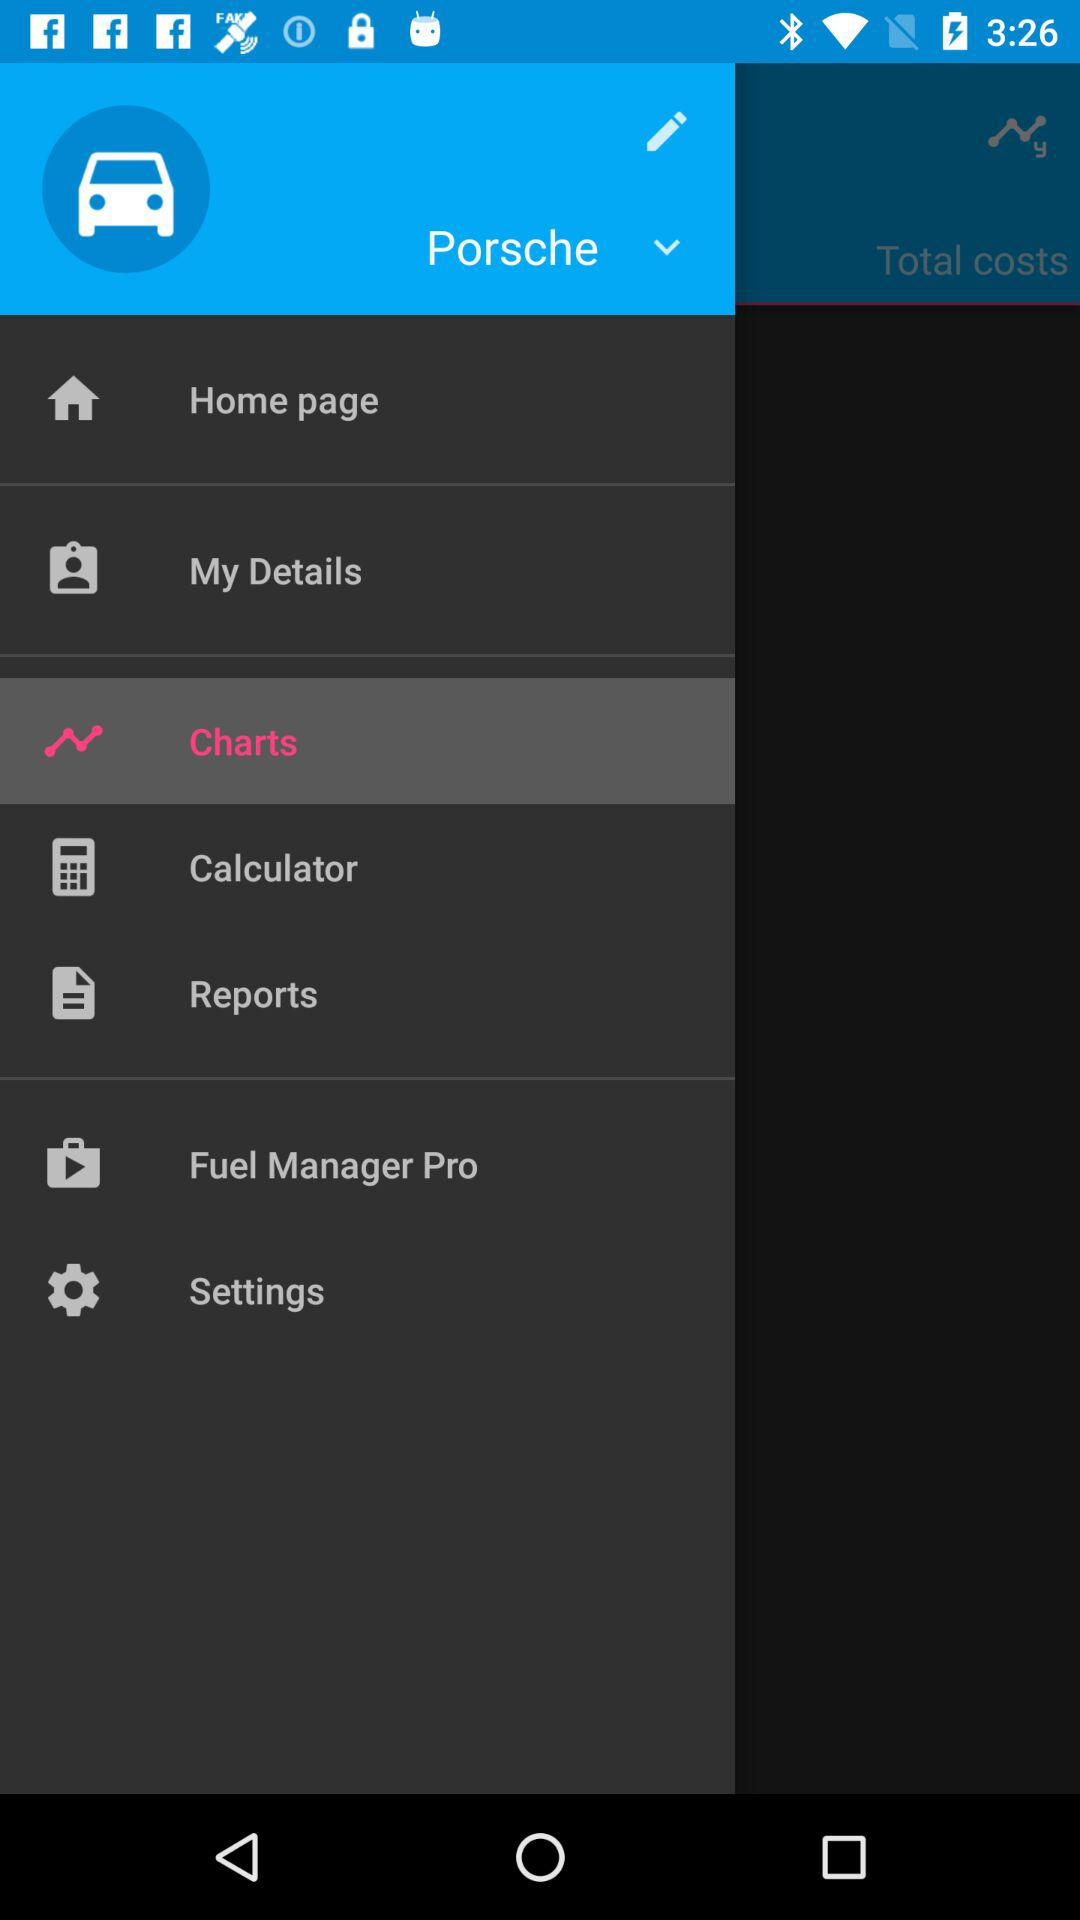What is the name of the vehicle? The name of the vehicle is "Porsche". 